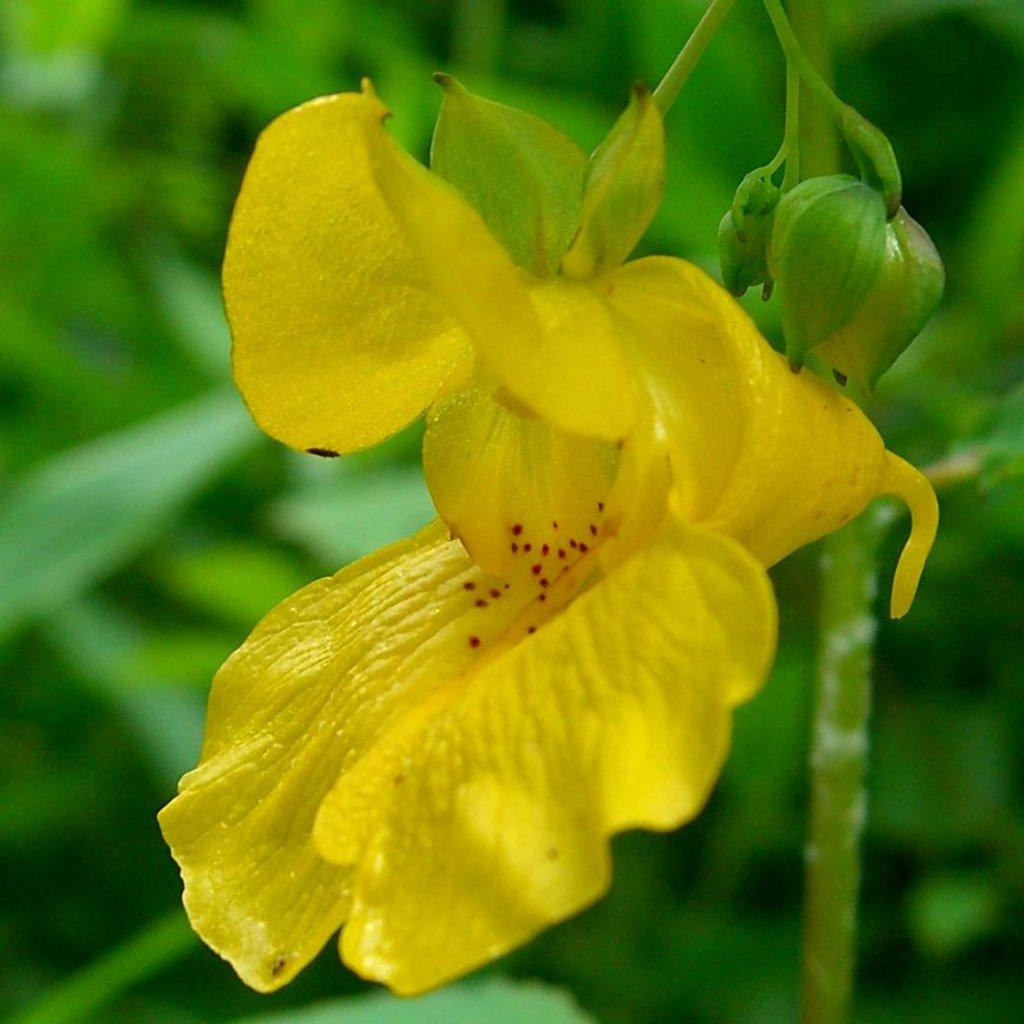What type of flower is in the image? There is a yellow flower in the image. What stage of growth are the flower's buds in? The flower has buds. What color are the leaves in the background of the image? There are green leaves in the background of the image. How would you describe the overall clarity of the image? The image is blurred. Can you see any farm animals in the image? There are no farm animals present in the image; it features a yellow flower with buds and green leaves in the background. What type of cemetery is depicted in the image? There is no cemetery present in the image; it features a yellow flower with buds and green leaves in the background. 